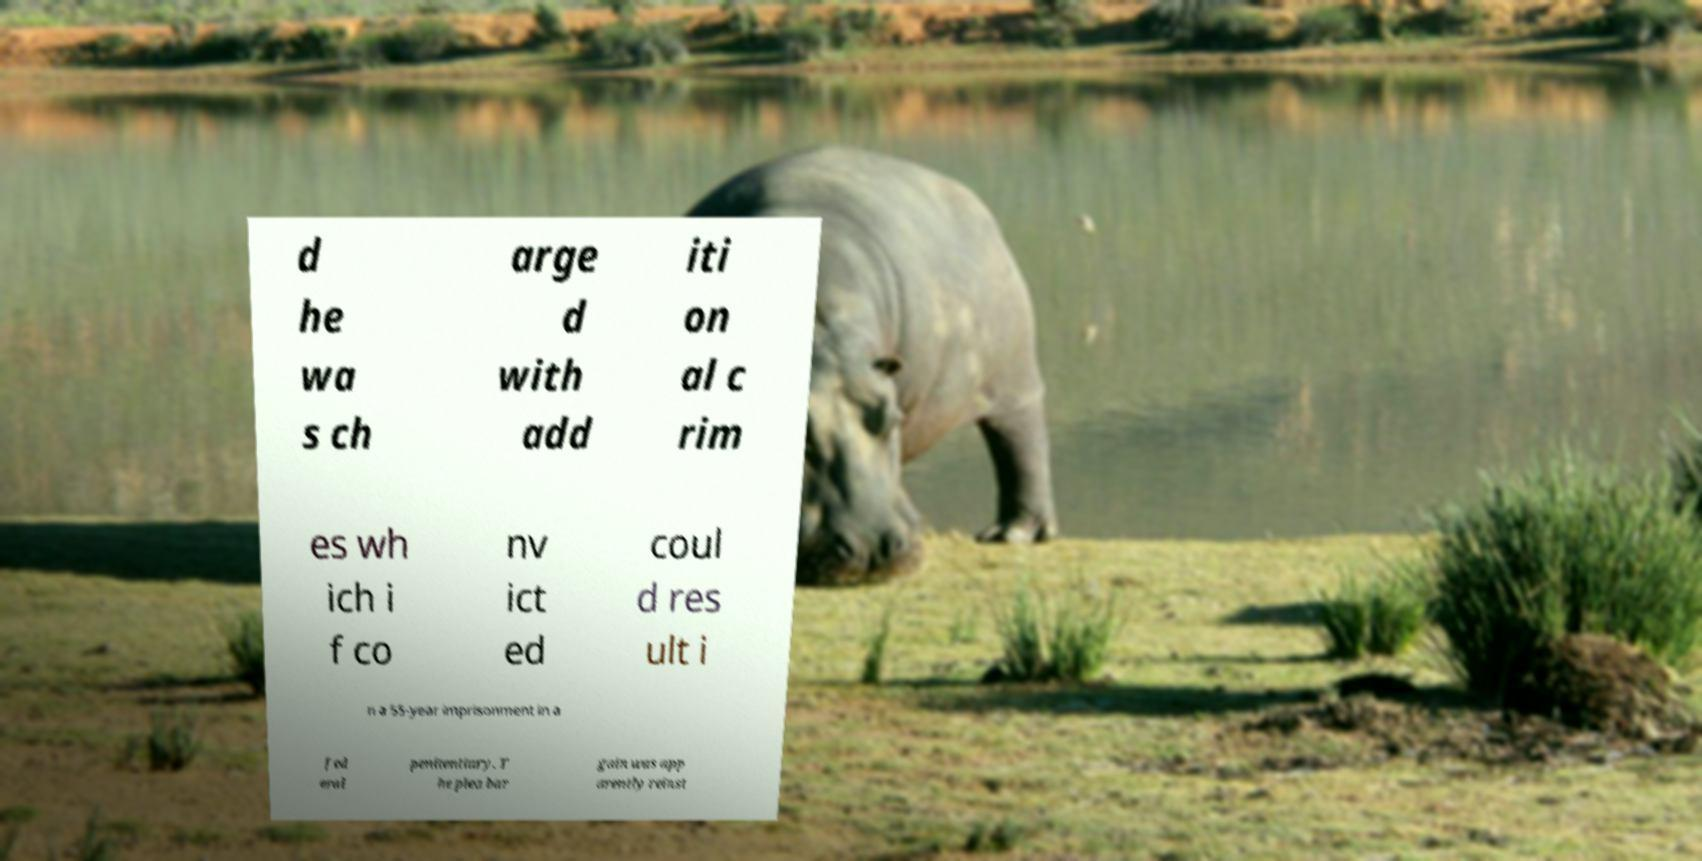Please read and relay the text visible in this image. What does it say? d he wa s ch arge d with add iti on al c rim es wh ich i f co nv ict ed coul d res ult i n a 55-year imprisonment in a fed eral penitentiary. T he plea bar gain was app arently reinst 